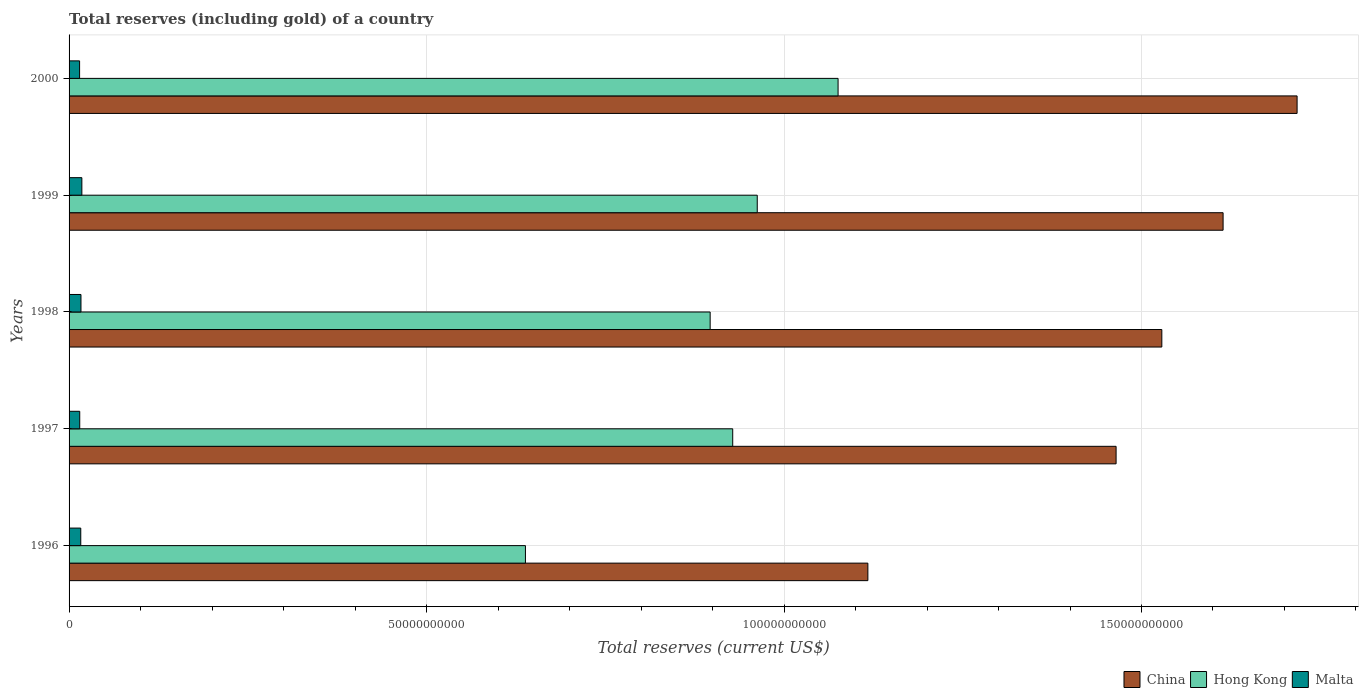How many different coloured bars are there?
Keep it short and to the point. 3. How many groups of bars are there?
Your answer should be compact. 5. Are the number of bars on each tick of the Y-axis equal?
Your response must be concise. Yes. How many bars are there on the 3rd tick from the top?
Offer a terse response. 3. How many bars are there on the 2nd tick from the bottom?
Make the answer very short. 3. What is the total reserves (including gold) in Hong Kong in 1998?
Your answer should be compact. 8.97e+1. Across all years, what is the maximum total reserves (including gold) in Malta?
Make the answer very short. 1.79e+09. Across all years, what is the minimum total reserves (including gold) in Hong Kong?
Your answer should be very brief. 6.38e+1. In which year was the total reserves (including gold) in China minimum?
Make the answer very short. 1996. What is the total total reserves (including gold) in Hong Kong in the graph?
Provide a succinct answer. 4.50e+11. What is the difference between the total reserves (including gold) in Malta in 1998 and that in 1999?
Provide a succinct answer. -1.25e+08. What is the difference between the total reserves (including gold) in China in 1996 and the total reserves (including gold) in Hong Kong in 2000?
Your response must be concise. 4.17e+09. What is the average total reserves (including gold) in China per year?
Provide a short and direct response. 1.49e+11. In the year 1997, what is the difference between the total reserves (including gold) in China and total reserves (including gold) in Hong Kong?
Give a very brief answer. 5.36e+1. In how many years, is the total reserves (including gold) in Hong Kong greater than 20000000000 US$?
Provide a succinct answer. 5. What is the ratio of the total reserves (including gold) in Malta in 1996 to that in 1997?
Your response must be concise. 1.1. Is the difference between the total reserves (including gold) in China in 1996 and 1998 greater than the difference between the total reserves (including gold) in Hong Kong in 1996 and 1998?
Offer a very short reply. No. What is the difference between the highest and the second highest total reserves (including gold) in Malta?
Your response must be concise. 1.25e+08. What is the difference between the highest and the lowest total reserves (including gold) in Malta?
Ensure brevity in your answer.  3.18e+08. In how many years, is the total reserves (including gold) in China greater than the average total reserves (including gold) in China taken over all years?
Offer a very short reply. 3. Is the sum of the total reserves (including gold) in Hong Kong in 1999 and 2000 greater than the maximum total reserves (including gold) in Malta across all years?
Keep it short and to the point. Yes. What does the 3rd bar from the top in 1999 represents?
Keep it short and to the point. China. What does the 2nd bar from the bottom in 1998 represents?
Offer a terse response. Hong Kong. Is it the case that in every year, the sum of the total reserves (including gold) in Malta and total reserves (including gold) in China is greater than the total reserves (including gold) in Hong Kong?
Ensure brevity in your answer.  Yes. How many bars are there?
Your answer should be very brief. 15. Are all the bars in the graph horizontal?
Your answer should be very brief. Yes. Does the graph contain any zero values?
Give a very brief answer. No. How many legend labels are there?
Offer a terse response. 3. How are the legend labels stacked?
Your answer should be compact. Horizontal. What is the title of the graph?
Your answer should be compact. Total reserves (including gold) of a country. What is the label or title of the X-axis?
Keep it short and to the point. Total reserves (current US$). What is the Total reserves (current US$) in China in 1996?
Offer a very short reply. 1.12e+11. What is the Total reserves (current US$) of Hong Kong in 1996?
Offer a very short reply. 6.38e+1. What is the Total reserves (current US$) in Malta in 1996?
Your answer should be compact. 1.64e+09. What is the Total reserves (current US$) in China in 1997?
Provide a short and direct response. 1.46e+11. What is the Total reserves (current US$) in Hong Kong in 1997?
Ensure brevity in your answer.  9.28e+1. What is the Total reserves (current US$) of Malta in 1997?
Keep it short and to the point. 1.49e+09. What is the Total reserves (current US$) in China in 1998?
Your response must be concise. 1.53e+11. What is the Total reserves (current US$) of Hong Kong in 1998?
Your answer should be very brief. 8.97e+1. What is the Total reserves (current US$) of Malta in 1998?
Your response must be concise. 1.66e+09. What is the Total reserves (current US$) in China in 1999?
Provide a succinct answer. 1.61e+11. What is the Total reserves (current US$) of Hong Kong in 1999?
Offer a very short reply. 9.63e+1. What is the Total reserves (current US$) of Malta in 1999?
Your answer should be very brief. 1.79e+09. What is the Total reserves (current US$) of China in 2000?
Make the answer very short. 1.72e+11. What is the Total reserves (current US$) of Hong Kong in 2000?
Make the answer very short. 1.08e+11. What is the Total reserves (current US$) in Malta in 2000?
Provide a succinct answer. 1.47e+09. Across all years, what is the maximum Total reserves (current US$) of China?
Offer a very short reply. 1.72e+11. Across all years, what is the maximum Total reserves (current US$) of Hong Kong?
Make the answer very short. 1.08e+11. Across all years, what is the maximum Total reserves (current US$) of Malta?
Your answer should be very brief. 1.79e+09. Across all years, what is the minimum Total reserves (current US$) in China?
Offer a very short reply. 1.12e+11. Across all years, what is the minimum Total reserves (current US$) of Hong Kong?
Offer a very short reply. 6.38e+1. Across all years, what is the minimum Total reserves (current US$) of Malta?
Give a very brief answer. 1.47e+09. What is the total Total reserves (current US$) of China in the graph?
Ensure brevity in your answer.  7.44e+11. What is the total Total reserves (current US$) of Hong Kong in the graph?
Your response must be concise. 4.50e+11. What is the total Total reserves (current US$) in Malta in the graph?
Your answer should be very brief. 8.05e+09. What is the difference between the Total reserves (current US$) of China in 1996 and that in 1997?
Provide a short and direct response. -3.47e+1. What is the difference between the Total reserves (current US$) of Hong Kong in 1996 and that in 1997?
Keep it short and to the point. -2.90e+1. What is the difference between the Total reserves (current US$) of Malta in 1996 and that in 1997?
Provide a succinct answer. 1.45e+08. What is the difference between the Total reserves (current US$) in China in 1996 and that in 1998?
Provide a short and direct response. -4.11e+1. What is the difference between the Total reserves (current US$) of Hong Kong in 1996 and that in 1998?
Make the answer very short. -2.58e+1. What is the difference between the Total reserves (current US$) in Malta in 1996 and that in 1998?
Ensure brevity in your answer.  -2.84e+07. What is the difference between the Total reserves (current US$) in China in 1996 and that in 1999?
Your answer should be very brief. -4.97e+1. What is the difference between the Total reserves (current US$) in Hong Kong in 1996 and that in 1999?
Offer a very short reply. -3.24e+1. What is the difference between the Total reserves (current US$) in Malta in 1996 and that in 1999?
Provide a short and direct response. -1.54e+08. What is the difference between the Total reserves (current US$) of China in 1996 and that in 2000?
Your answer should be compact. -6.00e+1. What is the difference between the Total reserves (current US$) of Hong Kong in 1996 and that in 2000?
Your answer should be very brief. -4.37e+1. What is the difference between the Total reserves (current US$) in Malta in 1996 and that in 2000?
Offer a terse response. 1.65e+08. What is the difference between the Total reserves (current US$) in China in 1997 and that in 1998?
Provide a succinct answer. -6.39e+09. What is the difference between the Total reserves (current US$) in Hong Kong in 1997 and that in 1998?
Provide a succinct answer. 3.15e+09. What is the difference between the Total reserves (current US$) in Malta in 1997 and that in 1998?
Keep it short and to the point. -1.74e+08. What is the difference between the Total reserves (current US$) in China in 1997 and that in 1999?
Make the answer very short. -1.50e+1. What is the difference between the Total reserves (current US$) in Hong Kong in 1997 and that in 1999?
Provide a short and direct response. -3.43e+09. What is the difference between the Total reserves (current US$) of Malta in 1997 and that in 1999?
Provide a succinct answer. -2.99e+08. What is the difference between the Total reserves (current US$) of China in 1997 and that in 2000?
Give a very brief answer. -2.53e+1. What is the difference between the Total reserves (current US$) in Hong Kong in 1997 and that in 2000?
Keep it short and to the point. -1.47e+1. What is the difference between the Total reserves (current US$) in Malta in 1997 and that in 2000?
Your answer should be very brief. 1.95e+07. What is the difference between the Total reserves (current US$) in China in 1998 and that in 1999?
Your answer should be very brief. -8.57e+09. What is the difference between the Total reserves (current US$) of Hong Kong in 1998 and that in 1999?
Offer a terse response. -6.59e+09. What is the difference between the Total reserves (current US$) in Malta in 1998 and that in 1999?
Make the answer very short. -1.25e+08. What is the difference between the Total reserves (current US$) of China in 1998 and that in 2000?
Ensure brevity in your answer.  -1.89e+1. What is the difference between the Total reserves (current US$) in Hong Kong in 1998 and that in 2000?
Your answer should be very brief. -1.79e+1. What is the difference between the Total reserves (current US$) in Malta in 1998 and that in 2000?
Provide a short and direct response. 1.93e+08. What is the difference between the Total reserves (current US$) in China in 1999 and that in 2000?
Give a very brief answer. -1.03e+1. What is the difference between the Total reserves (current US$) in Hong Kong in 1999 and that in 2000?
Offer a very short reply. -1.13e+1. What is the difference between the Total reserves (current US$) of Malta in 1999 and that in 2000?
Keep it short and to the point. 3.18e+08. What is the difference between the Total reserves (current US$) in China in 1996 and the Total reserves (current US$) in Hong Kong in 1997?
Give a very brief answer. 1.89e+1. What is the difference between the Total reserves (current US$) of China in 1996 and the Total reserves (current US$) of Malta in 1997?
Ensure brevity in your answer.  1.10e+11. What is the difference between the Total reserves (current US$) of Hong Kong in 1996 and the Total reserves (current US$) of Malta in 1997?
Your response must be concise. 6.23e+1. What is the difference between the Total reserves (current US$) of China in 1996 and the Total reserves (current US$) of Hong Kong in 1998?
Your answer should be compact. 2.21e+1. What is the difference between the Total reserves (current US$) of China in 1996 and the Total reserves (current US$) of Malta in 1998?
Your answer should be compact. 1.10e+11. What is the difference between the Total reserves (current US$) in Hong Kong in 1996 and the Total reserves (current US$) in Malta in 1998?
Ensure brevity in your answer.  6.22e+1. What is the difference between the Total reserves (current US$) of China in 1996 and the Total reserves (current US$) of Hong Kong in 1999?
Offer a very short reply. 1.55e+1. What is the difference between the Total reserves (current US$) of China in 1996 and the Total reserves (current US$) of Malta in 1999?
Your answer should be very brief. 1.10e+11. What is the difference between the Total reserves (current US$) in Hong Kong in 1996 and the Total reserves (current US$) in Malta in 1999?
Your answer should be compact. 6.20e+1. What is the difference between the Total reserves (current US$) in China in 1996 and the Total reserves (current US$) in Hong Kong in 2000?
Provide a succinct answer. 4.17e+09. What is the difference between the Total reserves (current US$) in China in 1996 and the Total reserves (current US$) in Malta in 2000?
Provide a succinct answer. 1.10e+11. What is the difference between the Total reserves (current US$) of Hong Kong in 1996 and the Total reserves (current US$) of Malta in 2000?
Ensure brevity in your answer.  6.24e+1. What is the difference between the Total reserves (current US$) in China in 1997 and the Total reserves (current US$) in Hong Kong in 1998?
Make the answer very short. 5.68e+1. What is the difference between the Total reserves (current US$) of China in 1997 and the Total reserves (current US$) of Malta in 1998?
Your answer should be very brief. 1.45e+11. What is the difference between the Total reserves (current US$) in Hong Kong in 1997 and the Total reserves (current US$) in Malta in 1998?
Provide a succinct answer. 9.12e+1. What is the difference between the Total reserves (current US$) in China in 1997 and the Total reserves (current US$) in Hong Kong in 1999?
Keep it short and to the point. 5.02e+1. What is the difference between the Total reserves (current US$) of China in 1997 and the Total reserves (current US$) of Malta in 1999?
Give a very brief answer. 1.45e+11. What is the difference between the Total reserves (current US$) in Hong Kong in 1997 and the Total reserves (current US$) in Malta in 1999?
Ensure brevity in your answer.  9.10e+1. What is the difference between the Total reserves (current US$) in China in 1997 and the Total reserves (current US$) in Hong Kong in 2000?
Provide a short and direct response. 3.89e+1. What is the difference between the Total reserves (current US$) of China in 1997 and the Total reserves (current US$) of Malta in 2000?
Make the answer very short. 1.45e+11. What is the difference between the Total reserves (current US$) of Hong Kong in 1997 and the Total reserves (current US$) of Malta in 2000?
Offer a terse response. 9.14e+1. What is the difference between the Total reserves (current US$) in China in 1998 and the Total reserves (current US$) in Hong Kong in 1999?
Ensure brevity in your answer.  5.66e+1. What is the difference between the Total reserves (current US$) in China in 1998 and the Total reserves (current US$) in Malta in 1999?
Provide a short and direct response. 1.51e+11. What is the difference between the Total reserves (current US$) of Hong Kong in 1998 and the Total reserves (current US$) of Malta in 1999?
Provide a succinct answer. 8.79e+1. What is the difference between the Total reserves (current US$) in China in 1998 and the Total reserves (current US$) in Hong Kong in 2000?
Keep it short and to the point. 4.53e+1. What is the difference between the Total reserves (current US$) in China in 1998 and the Total reserves (current US$) in Malta in 2000?
Ensure brevity in your answer.  1.51e+11. What is the difference between the Total reserves (current US$) of Hong Kong in 1998 and the Total reserves (current US$) of Malta in 2000?
Make the answer very short. 8.82e+1. What is the difference between the Total reserves (current US$) in China in 1999 and the Total reserves (current US$) in Hong Kong in 2000?
Your answer should be very brief. 5.39e+1. What is the difference between the Total reserves (current US$) of China in 1999 and the Total reserves (current US$) of Malta in 2000?
Your answer should be compact. 1.60e+11. What is the difference between the Total reserves (current US$) in Hong Kong in 1999 and the Total reserves (current US$) in Malta in 2000?
Offer a very short reply. 9.48e+1. What is the average Total reserves (current US$) of China per year?
Your answer should be compact. 1.49e+11. What is the average Total reserves (current US$) of Hong Kong per year?
Your answer should be very brief. 9.00e+1. What is the average Total reserves (current US$) of Malta per year?
Provide a short and direct response. 1.61e+09. In the year 1996, what is the difference between the Total reserves (current US$) in China and Total reserves (current US$) in Hong Kong?
Keep it short and to the point. 4.79e+1. In the year 1996, what is the difference between the Total reserves (current US$) in China and Total reserves (current US$) in Malta?
Keep it short and to the point. 1.10e+11. In the year 1996, what is the difference between the Total reserves (current US$) in Hong Kong and Total reserves (current US$) in Malta?
Give a very brief answer. 6.22e+1. In the year 1997, what is the difference between the Total reserves (current US$) of China and Total reserves (current US$) of Hong Kong?
Make the answer very short. 5.36e+1. In the year 1997, what is the difference between the Total reserves (current US$) of China and Total reserves (current US$) of Malta?
Your answer should be compact. 1.45e+11. In the year 1997, what is the difference between the Total reserves (current US$) in Hong Kong and Total reserves (current US$) in Malta?
Your response must be concise. 9.13e+1. In the year 1998, what is the difference between the Total reserves (current US$) in China and Total reserves (current US$) in Hong Kong?
Make the answer very short. 6.32e+1. In the year 1998, what is the difference between the Total reserves (current US$) of China and Total reserves (current US$) of Malta?
Keep it short and to the point. 1.51e+11. In the year 1998, what is the difference between the Total reserves (current US$) in Hong Kong and Total reserves (current US$) in Malta?
Your answer should be very brief. 8.80e+1. In the year 1999, what is the difference between the Total reserves (current US$) of China and Total reserves (current US$) of Hong Kong?
Offer a terse response. 6.52e+1. In the year 1999, what is the difference between the Total reserves (current US$) in China and Total reserves (current US$) in Malta?
Ensure brevity in your answer.  1.60e+11. In the year 1999, what is the difference between the Total reserves (current US$) of Hong Kong and Total reserves (current US$) of Malta?
Provide a succinct answer. 9.45e+1. In the year 2000, what is the difference between the Total reserves (current US$) in China and Total reserves (current US$) in Hong Kong?
Offer a terse response. 6.42e+1. In the year 2000, what is the difference between the Total reserves (current US$) in China and Total reserves (current US$) in Malta?
Keep it short and to the point. 1.70e+11. In the year 2000, what is the difference between the Total reserves (current US$) of Hong Kong and Total reserves (current US$) of Malta?
Offer a terse response. 1.06e+11. What is the ratio of the Total reserves (current US$) in China in 1996 to that in 1997?
Give a very brief answer. 0.76. What is the ratio of the Total reserves (current US$) in Hong Kong in 1996 to that in 1997?
Your response must be concise. 0.69. What is the ratio of the Total reserves (current US$) of Malta in 1996 to that in 1997?
Your response must be concise. 1.1. What is the ratio of the Total reserves (current US$) of China in 1996 to that in 1998?
Give a very brief answer. 0.73. What is the ratio of the Total reserves (current US$) in Hong Kong in 1996 to that in 1998?
Provide a short and direct response. 0.71. What is the ratio of the Total reserves (current US$) in China in 1996 to that in 1999?
Provide a succinct answer. 0.69. What is the ratio of the Total reserves (current US$) in Hong Kong in 1996 to that in 1999?
Your answer should be compact. 0.66. What is the ratio of the Total reserves (current US$) in Malta in 1996 to that in 1999?
Make the answer very short. 0.91. What is the ratio of the Total reserves (current US$) of China in 1996 to that in 2000?
Your response must be concise. 0.65. What is the ratio of the Total reserves (current US$) of Hong Kong in 1996 to that in 2000?
Keep it short and to the point. 0.59. What is the ratio of the Total reserves (current US$) in Malta in 1996 to that in 2000?
Offer a terse response. 1.11. What is the ratio of the Total reserves (current US$) in China in 1997 to that in 1998?
Your response must be concise. 0.96. What is the ratio of the Total reserves (current US$) of Hong Kong in 1997 to that in 1998?
Offer a very short reply. 1.04. What is the ratio of the Total reserves (current US$) in Malta in 1997 to that in 1998?
Ensure brevity in your answer.  0.9. What is the ratio of the Total reserves (current US$) of China in 1997 to that in 1999?
Give a very brief answer. 0.91. What is the ratio of the Total reserves (current US$) of Malta in 1997 to that in 1999?
Offer a very short reply. 0.83. What is the ratio of the Total reserves (current US$) of China in 1997 to that in 2000?
Keep it short and to the point. 0.85. What is the ratio of the Total reserves (current US$) of Hong Kong in 1997 to that in 2000?
Provide a succinct answer. 0.86. What is the ratio of the Total reserves (current US$) in Malta in 1997 to that in 2000?
Provide a succinct answer. 1.01. What is the ratio of the Total reserves (current US$) of China in 1998 to that in 1999?
Your answer should be compact. 0.95. What is the ratio of the Total reserves (current US$) of Hong Kong in 1998 to that in 1999?
Ensure brevity in your answer.  0.93. What is the ratio of the Total reserves (current US$) of Malta in 1998 to that in 1999?
Your answer should be compact. 0.93. What is the ratio of the Total reserves (current US$) in China in 1998 to that in 2000?
Your answer should be compact. 0.89. What is the ratio of the Total reserves (current US$) of Hong Kong in 1998 to that in 2000?
Your answer should be compact. 0.83. What is the ratio of the Total reserves (current US$) of Malta in 1998 to that in 2000?
Ensure brevity in your answer.  1.13. What is the ratio of the Total reserves (current US$) in China in 1999 to that in 2000?
Ensure brevity in your answer.  0.94. What is the ratio of the Total reserves (current US$) in Hong Kong in 1999 to that in 2000?
Offer a very short reply. 0.89. What is the ratio of the Total reserves (current US$) in Malta in 1999 to that in 2000?
Make the answer very short. 1.22. What is the difference between the highest and the second highest Total reserves (current US$) of China?
Offer a terse response. 1.03e+1. What is the difference between the highest and the second highest Total reserves (current US$) in Hong Kong?
Your answer should be compact. 1.13e+1. What is the difference between the highest and the second highest Total reserves (current US$) in Malta?
Provide a short and direct response. 1.25e+08. What is the difference between the highest and the lowest Total reserves (current US$) in China?
Ensure brevity in your answer.  6.00e+1. What is the difference between the highest and the lowest Total reserves (current US$) in Hong Kong?
Keep it short and to the point. 4.37e+1. What is the difference between the highest and the lowest Total reserves (current US$) in Malta?
Provide a short and direct response. 3.18e+08. 